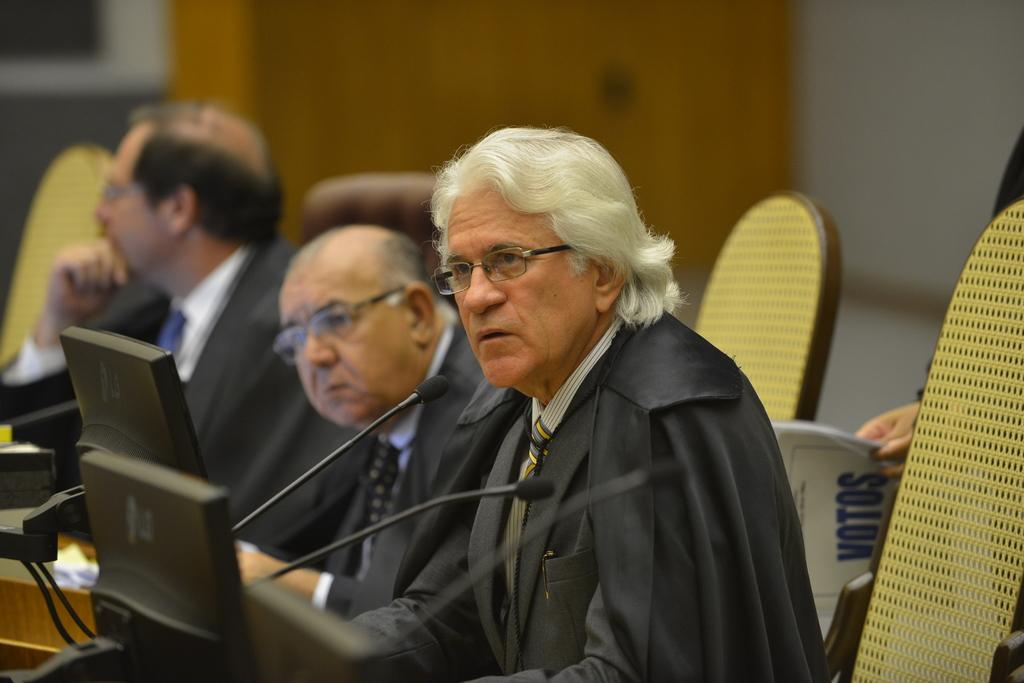How many people are in the image? There are three people in the image. What are the people doing in the image? The people are sitting on chairs. What are the people wearing in the image? The people are wearing suits. What objects are present in the image that are related to communication? There are microphones (mics) placed before the people. What can be seen in the background of the image? There is a wall in the background of the image. What type of harmony can be heard in the image? There is no audible sound in the image, so it is not possible to determine the type of harmony. 